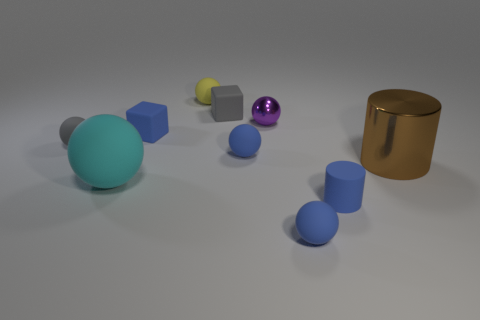Subtract all gray balls. How many balls are left? 5 Subtract all purple balls. How many balls are left? 5 Subtract all cylinders. How many objects are left? 8 Subtract 2 blocks. How many blocks are left? 0 Subtract all yellow cubes. Subtract all yellow spheres. How many cubes are left? 2 Subtract all gray spheres. How many gray cubes are left? 1 Subtract all big blue metal things. Subtract all cylinders. How many objects are left? 8 Add 1 brown metallic objects. How many brown metallic objects are left? 2 Add 3 tiny purple balls. How many tiny purple balls exist? 4 Subtract 1 yellow spheres. How many objects are left? 9 